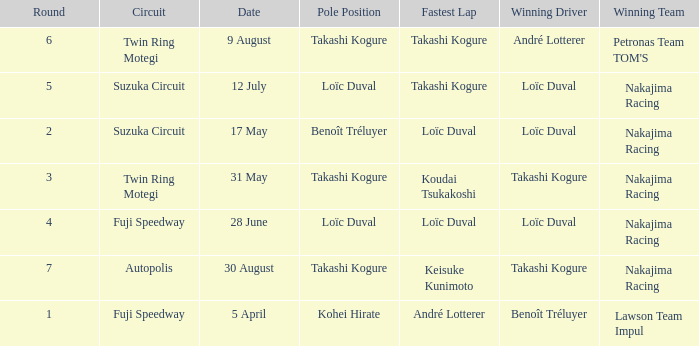What was the earlier round where Takashi Kogure got the fastest lap? 5.0. 